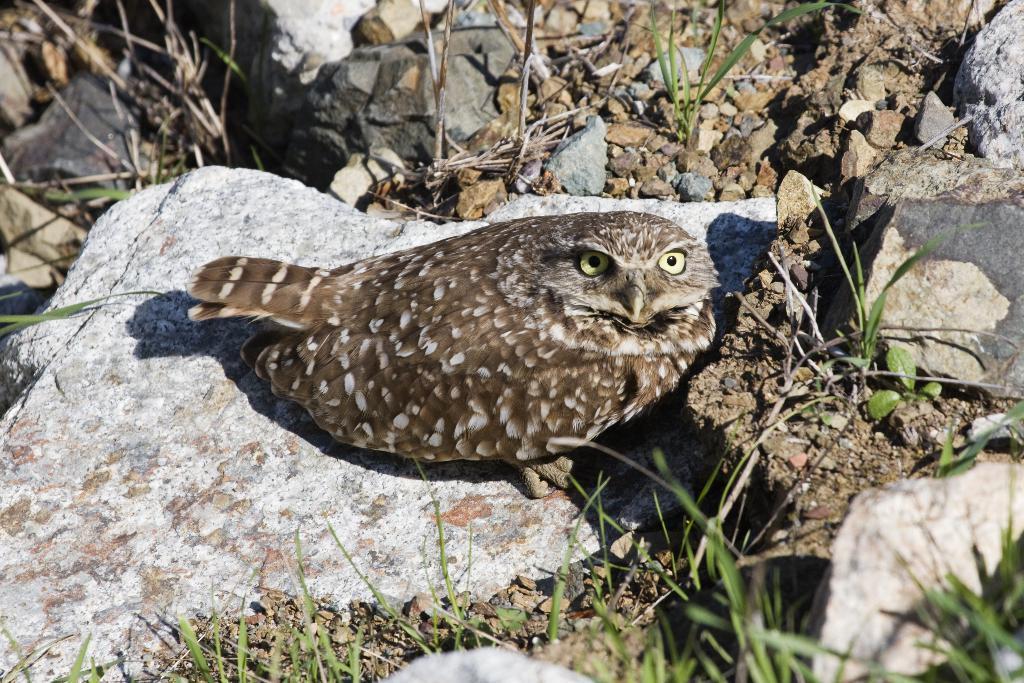Please provide a concise description of this image. In the center of the image there is an owl on the ground. In the background we can see stones and grass. 